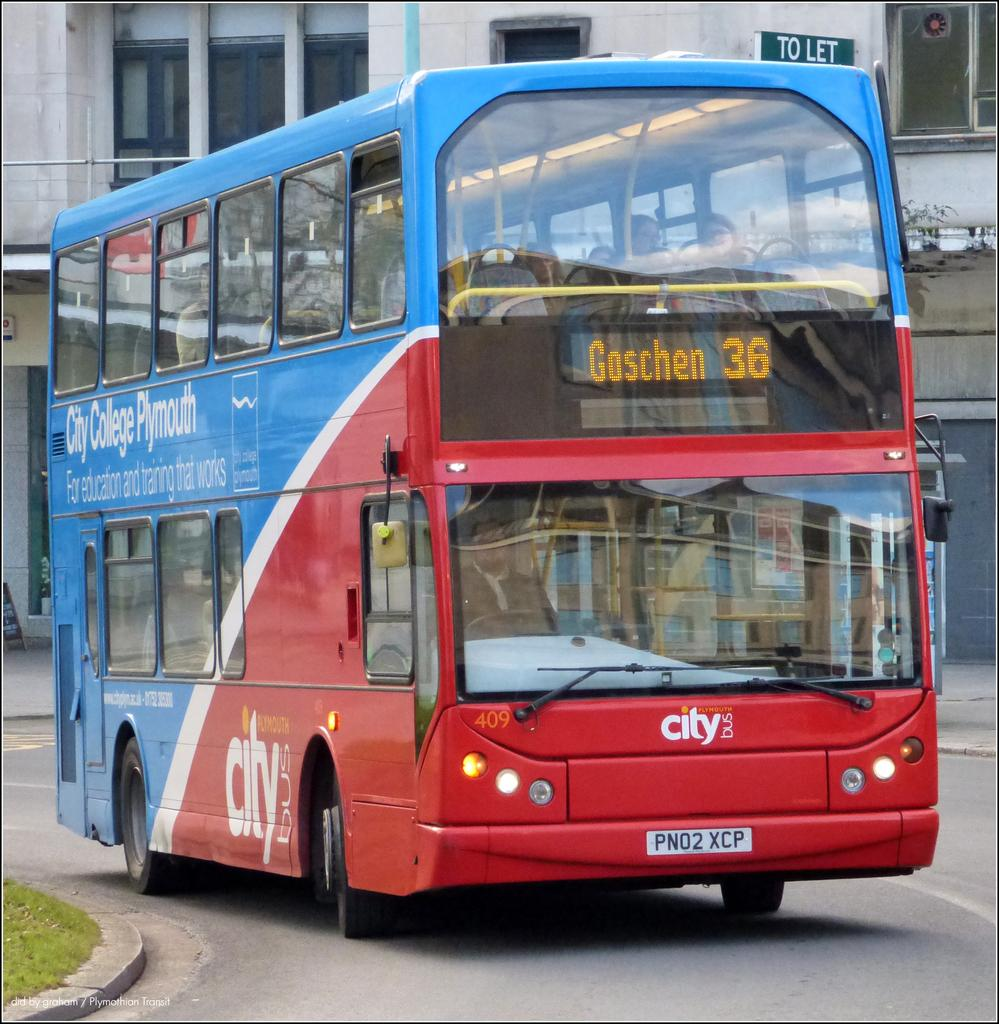<image>
Write a terse but informative summary of the picture. A double decker bus with Goschen 36 on the front 